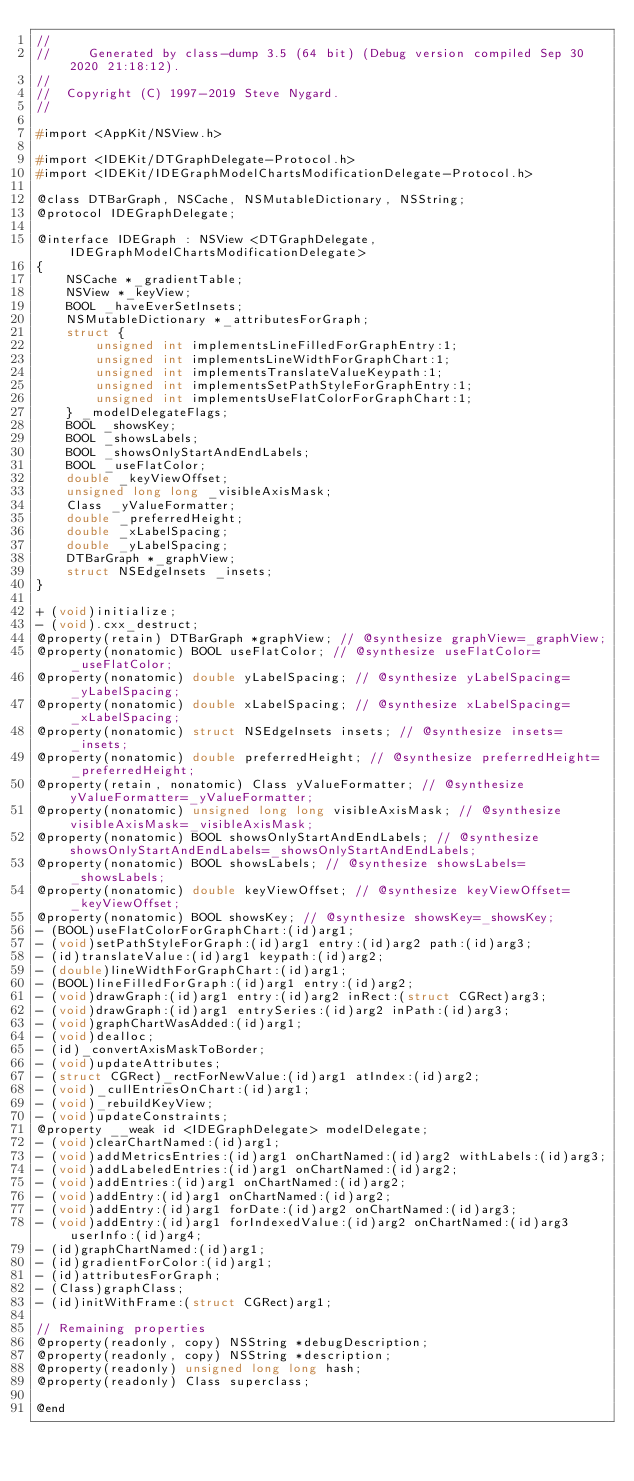<code> <loc_0><loc_0><loc_500><loc_500><_C_>//
//     Generated by class-dump 3.5 (64 bit) (Debug version compiled Sep 30 2020 21:18:12).
//
//  Copyright (C) 1997-2019 Steve Nygard.
//

#import <AppKit/NSView.h>

#import <IDEKit/DTGraphDelegate-Protocol.h>
#import <IDEKit/IDEGraphModelChartsModificationDelegate-Protocol.h>

@class DTBarGraph, NSCache, NSMutableDictionary, NSString;
@protocol IDEGraphDelegate;

@interface IDEGraph : NSView <DTGraphDelegate, IDEGraphModelChartsModificationDelegate>
{
    NSCache *_gradientTable;
    NSView *_keyView;
    BOOL _haveEverSetInsets;
    NSMutableDictionary *_attributesForGraph;
    struct {
        unsigned int implementsLineFilledForGraphEntry:1;
        unsigned int implementsLineWidthForGraphChart:1;
        unsigned int implementsTranslateValueKeypath:1;
        unsigned int implementsSetPathStyleForGraphEntry:1;
        unsigned int implementsUseFlatColorForGraphChart:1;
    } _modelDelegateFlags;
    BOOL _showsKey;
    BOOL _showsLabels;
    BOOL _showsOnlyStartAndEndLabels;
    BOOL _useFlatColor;
    double _keyViewOffset;
    unsigned long long _visibleAxisMask;
    Class _yValueFormatter;
    double _preferredHeight;
    double _xLabelSpacing;
    double _yLabelSpacing;
    DTBarGraph *_graphView;
    struct NSEdgeInsets _insets;
}

+ (void)initialize;
- (void).cxx_destruct;
@property(retain) DTBarGraph *graphView; // @synthesize graphView=_graphView;
@property(nonatomic) BOOL useFlatColor; // @synthesize useFlatColor=_useFlatColor;
@property(nonatomic) double yLabelSpacing; // @synthesize yLabelSpacing=_yLabelSpacing;
@property(nonatomic) double xLabelSpacing; // @synthesize xLabelSpacing=_xLabelSpacing;
@property(nonatomic) struct NSEdgeInsets insets; // @synthesize insets=_insets;
@property(nonatomic) double preferredHeight; // @synthesize preferredHeight=_preferredHeight;
@property(retain, nonatomic) Class yValueFormatter; // @synthesize yValueFormatter=_yValueFormatter;
@property(nonatomic) unsigned long long visibleAxisMask; // @synthesize visibleAxisMask=_visibleAxisMask;
@property(nonatomic) BOOL showsOnlyStartAndEndLabels; // @synthesize showsOnlyStartAndEndLabels=_showsOnlyStartAndEndLabels;
@property(nonatomic) BOOL showsLabels; // @synthesize showsLabels=_showsLabels;
@property(nonatomic) double keyViewOffset; // @synthesize keyViewOffset=_keyViewOffset;
@property(nonatomic) BOOL showsKey; // @synthesize showsKey=_showsKey;
- (BOOL)useFlatColorForGraphChart:(id)arg1;
- (void)setPathStyleForGraph:(id)arg1 entry:(id)arg2 path:(id)arg3;
- (id)translateValue:(id)arg1 keypath:(id)arg2;
- (double)lineWidthForGraphChart:(id)arg1;
- (BOOL)lineFilledForGraph:(id)arg1 entry:(id)arg2;
- (void)drawGraph:(id)arg1 entry:(id)arg2 inRect:(struct CGRect)arg3;
- (void)drawGraph:(id)arg1 entrySeries:(id)arg2 inPath:(id)arg3;
- (void)graphChartWasAdded:(id)arg1;
- (void)dealloc;
- (id)_convertAxisMaskToBorder;
- (void)updateAttributes;
- (struct CGRect)_rectForNewValue:(id)arg1 atIndex:(id)arg2;
- (void)_cullEntriesOnChart:(id)arg1;
- (void)_rebuildKeyView;
- (void)updateConstraints;
@property __weak id <IDEGraphDelegate> modelDelegate;
- (void)clearChartNamed:(id)arg1;
- (void)addMetricsEntries:(id)arg1 onChartNamed:(id)arg2 withLabels:(id)arg3;
- (void)addLabeledEntries:(id)arg1 onChartNamed:(id)arg2;
- (void)addEntries:(id)arg1 onChartNamed:(id)arg2;
- (void)addEntry:(id)arg1 onChartNamed:(id)arg2;
- (void)addEntry:(id)arg1 forDate:(id)arg2 onChartNamed:(id)arg3;
- (void)addEntry:(id)arg1 forIndexedValue:(id)arg2 onChartNamed:(id)arg3 userInfo:(id)arg4;
- (id)graphChartNamed:(id)arg1;
- (id)gradientForColor:(id)arg1;
- (id)attributesForGraph;
- (Class)graphClass;
- (id)initWithFrame:(struct CGRect)arg1;

// Remaining properties
@property(readonly, copy) NSString *debugDescription;
@property(readonly, copy) NSString *description;
@property(readonly) unsigned long long hash;
@property(readonly) Class superclass;

@end

</code> 